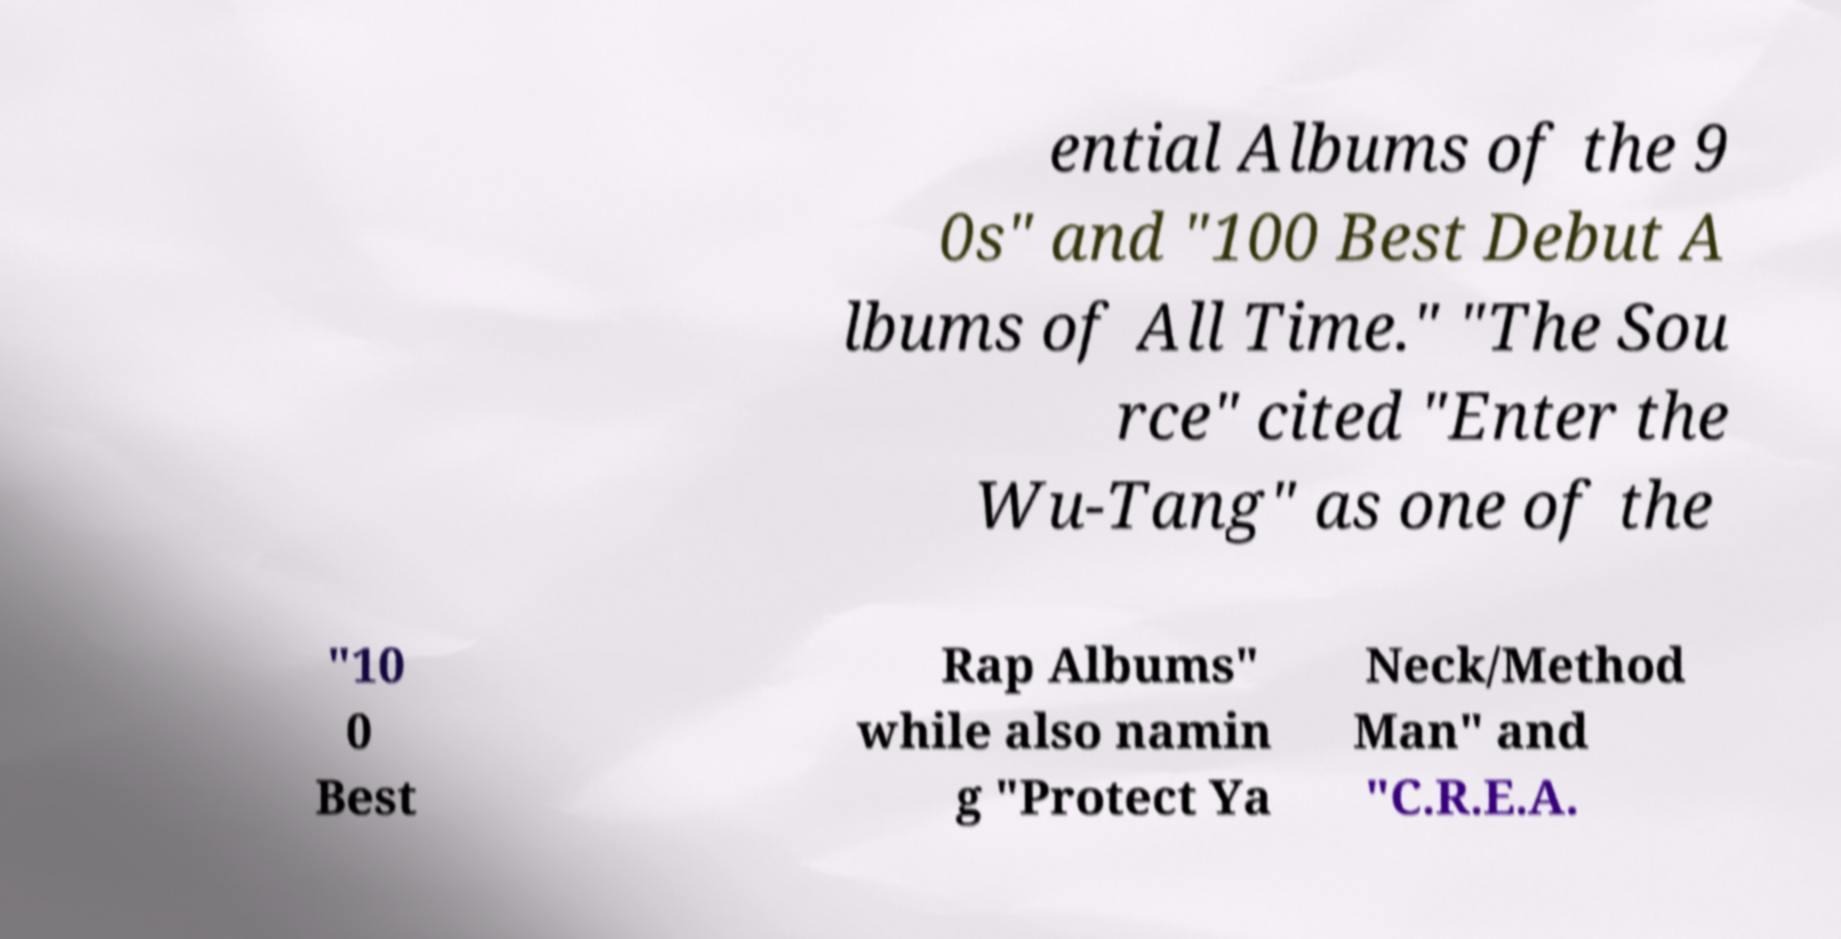I need the written content from this picture converted into text. Can you do that? ential Albums of the 9 0s" and "100 Best Debut A lbums of All Time." "The Sou rce" cited "Enter the Wu-Tang" as one of the "10 0 Best Rap Albums" while also namin g "Protect Ya Neck/Method Man" and "C.R.E.A. 